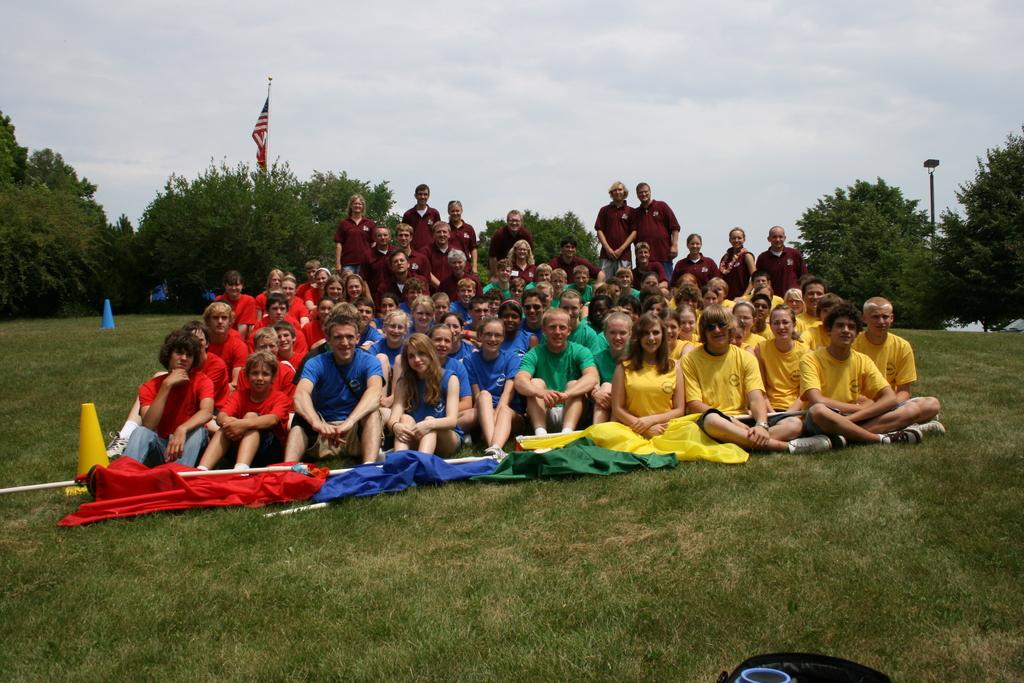How many people are in the image? There is a group of people in the image, but the exact number is not specified. What type of natural environment is visible in the image? There are trees, grass, and poles in the image, suggesting a natural setting. What is the purpose of the flag in the image? The presence of a flag in the image may indicate a specific event or location, but its exact purpose is not clear. What is the cone barricade used for in the image? The cone barricade may be used to direct traffic or indicate a hazard in the area, but its specific purpose is not clear. What object is located at the bottom of the image? There is an object at the bottom of the image, but its description is not provided. What type of insect can be seen crawling on the holiday decoration in the image? There is no insect or holiday decoration present in the image. How does the tongue of the person in the image taste the ice cream? There is no ice cream or person with a tongue visible in the image. 